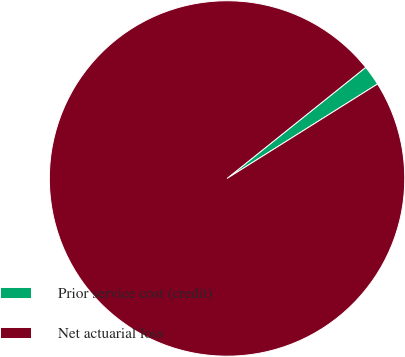Convert chart. <chart><loc_0><loc_0><loc_500><loc_500><pie_chart><fcel>Prior service cost (credit)<fcel>Net actuarial loss<nl><fcel>1.83%<fcel>98.17%<nl></chart> 